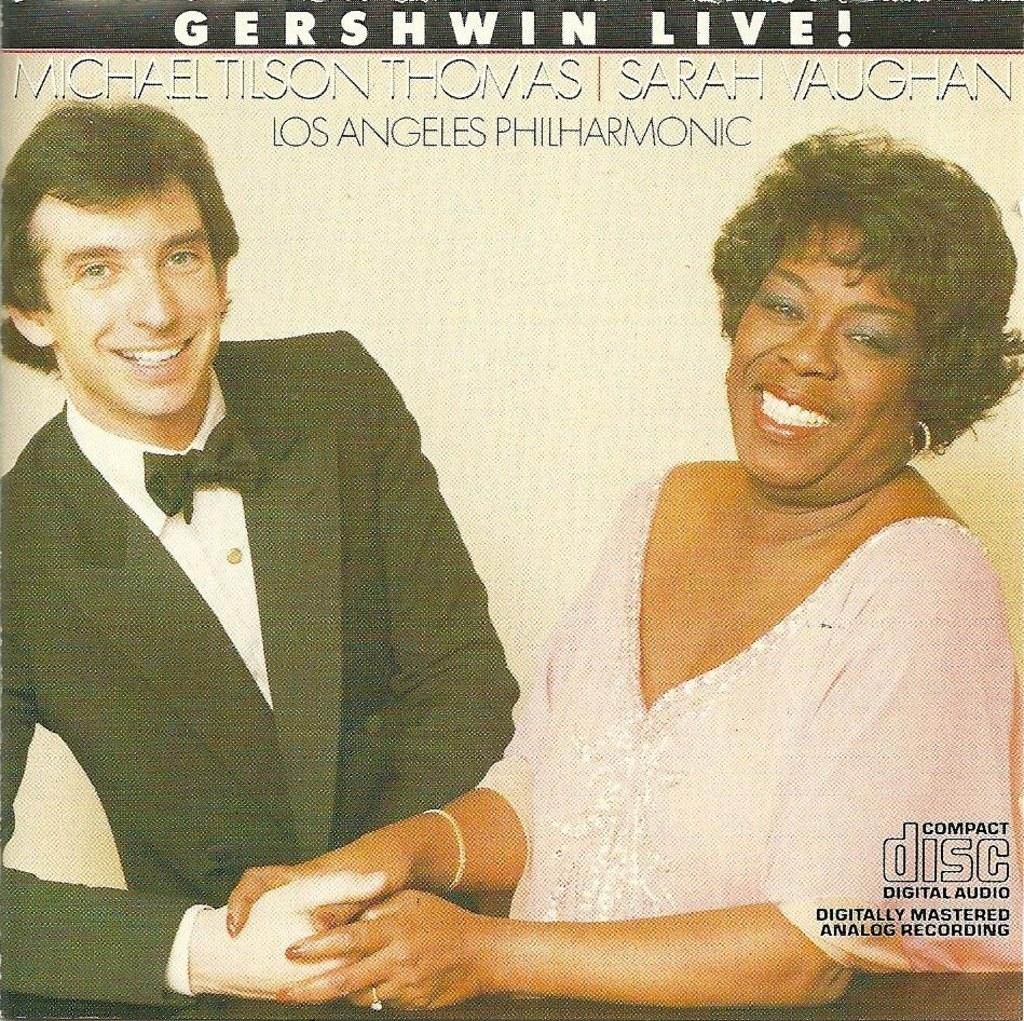How many people are in the image? There are two people in the image, a man and a woman. What are the man and woman doing in the image? The man and woman are both smiling, suggesting they are in a positive or happy situation. What type of accessories can be seen in the image? There is a finger ring, a bracelet, and earrings visible in the image. What else is present in the image besides the people and accessories? There is some text in the image. What scientific experiment is being conducted in the image? There is no scientific experiment present in the image; it features a man and woman with accessories and text. How many vacation days are the man and woman taking in the image? There is no indication of a vacation or any vacation-related information in the image. 